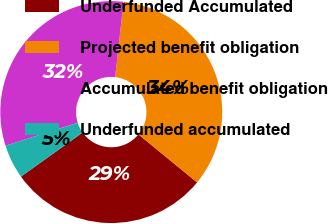<chart> <loc_0><loc_0><loc_500><loc_500><pie_chart><fcel>Underfunded Accumulated<fcel>Projected benefit obligation<fcel>Accumulated benefit obligation<fcel>Underfunded accumulated<nl><fcel>29.2%<fcel>34.16%<fcel>31.68%<fcel>4.97%<nl></chart> 